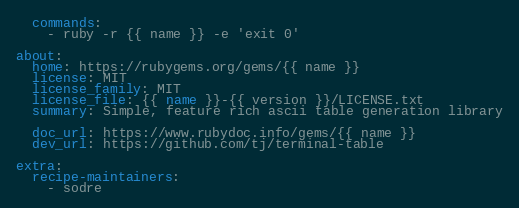Convert code to text. <code><loc_0><loc_0><loc_500><loc_500><_YAML_>  commands:
    - ruby -r {{ name }} -e 'exit 0'

about:
  home: https://rubygems.org/gems/{{ name }}
  license: MIT
  license_family: MIT
  license_file: {{ name }}-{{ version }}/LICENSE.txt
  summary: Simple, feature rich ascii table generation library

  doc_url: https://www.rubydoc.info/gems/{{ name }}
  dev_url: https://github.com/tj/terminal-table

extra:
  recipe-maintainers:
    - sodre
</code> 